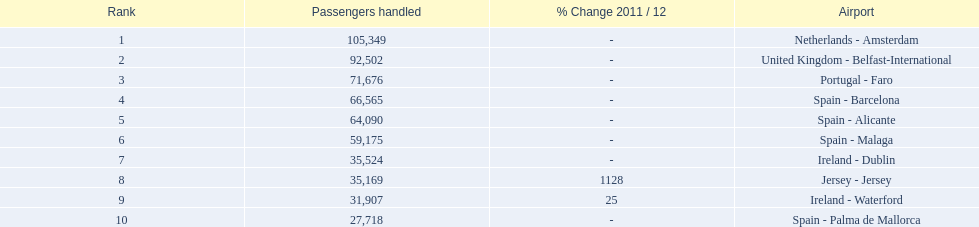What is the highest number of passengers handled? 105,349. What is the destination of the passengers leaving the area that handles 105,349 travellers? Netherlands - Amsterdam. 